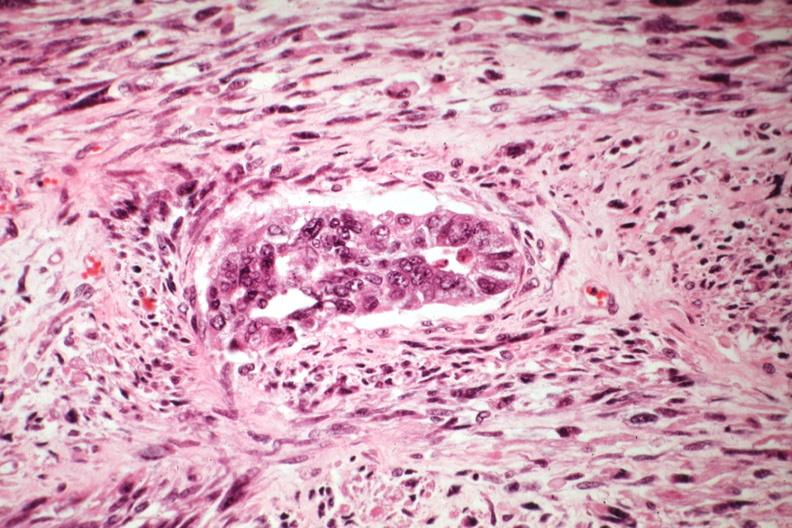s uterus present?
Answer the question using a single word or phrase. Yes 